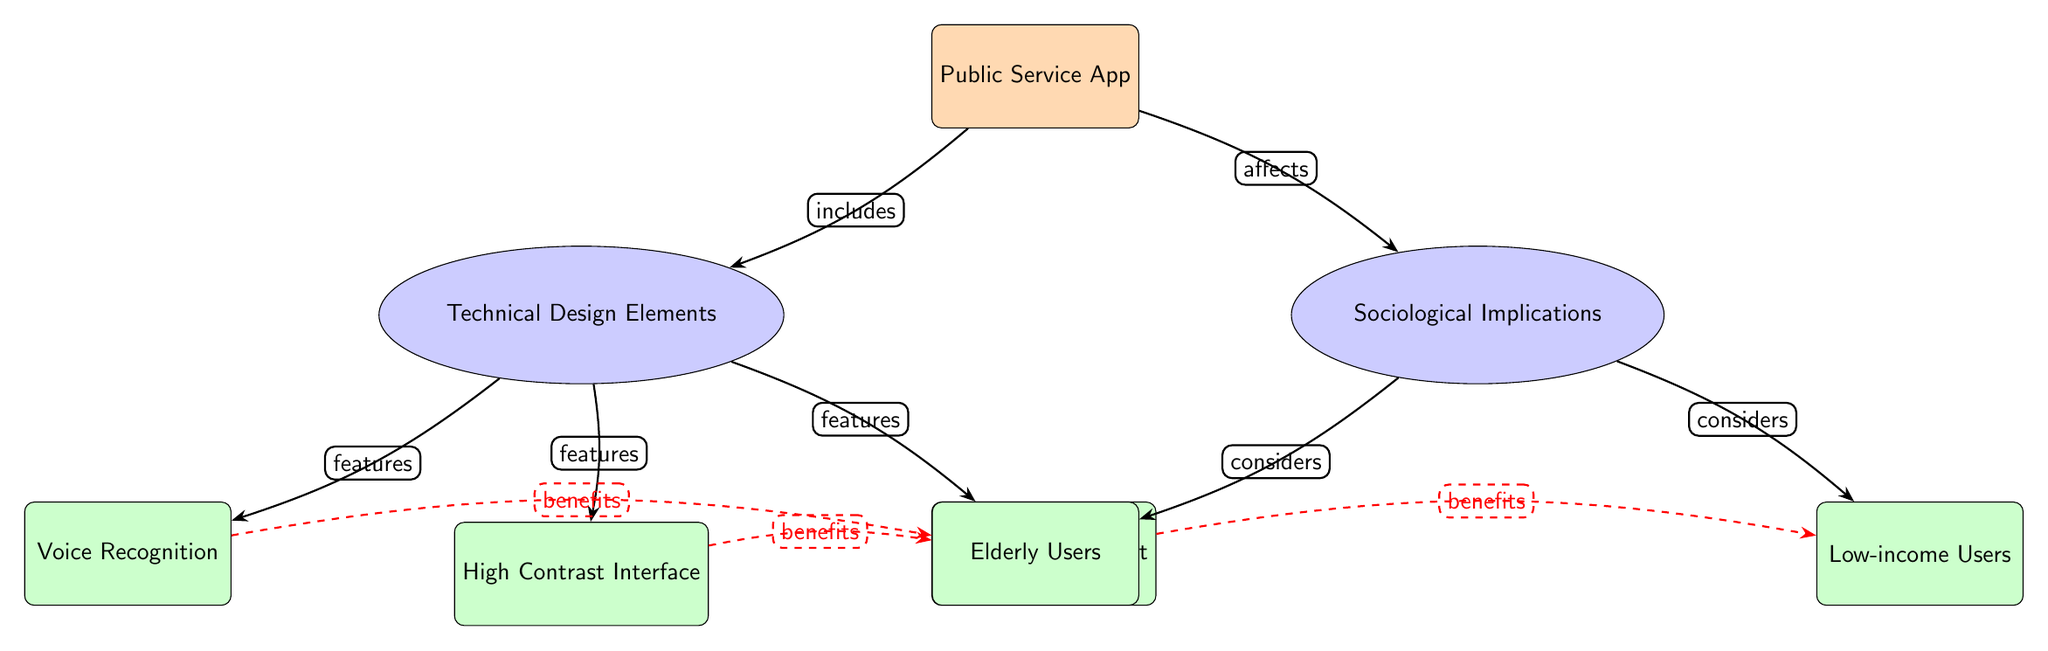What are the main categories represented in the diagram? The diagram has two main categories: Technical Design Elements and Sociological Implications. Each category branches out to feature specific nodes that detail aspects related to the Public Service App.
Answer: Technical Design Elements, Sociological Implications How many technical design elements are listed in the diagram? The diagram outlines three specific technical design elements: Voice Recognition, High Contrast Interface, and Multilingual Support. Each of these elements is represented as tertiary nodes under the Technical Design Elements category.
Answer: Three What user demographic does the sociological implications section primarily consider? The sociological implications section considers two user demographics: Elderly Users and Low-income Users. These demographics make up the tertiary nodes under the Sociological Implications category.
Answer: Elderly Users, Low-income Users What technical feature benefits elderly users according to the diagram? The diagram indicates that both Voice Recognition and High Contrast Interface are technical features that specifically benefit elderly users, as denoted by the dashed red edges connecting these features to the Elderly Users node.
Answer: Voice Recognition, High Contrast Interface What relationship exists between the Public Service App and its components? The Public Service App includes the Technical Design Elements and affects the Sociological Implications, as shown by the direct connections stemming from the App node to both categories.
Answer: includes, affects What type of connection is illustrated between the Multilingual Support feature and Low-income Users? The connection shown is a dashed red line marked as "benefits," which implies that Multilingual Support is specifically beneficial for Low-income Users, indicating an important sociological consideration for this demographic.
Answer: benefits 